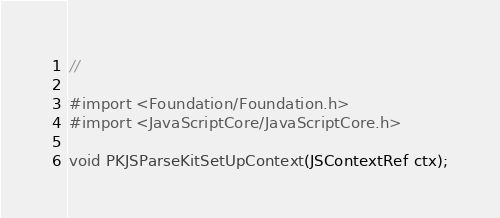<code> <loc_0><loc_0><loc_500><loc_500><_C_>//

#import <Foundation/Foundation.h>
#import <JavaScriptCore/JavaScriptCore.h>

void PKJSParseKitSetUpContext(JSContextRef ctx);</code> 